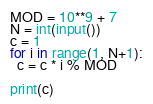Convert code to text. <code><loc_0><loc_0><loc_500><loc_500><_Python_>MOD = 10**9 + 7
N = int(input())
c = 1
for i in range(1, N+1):
  c = c * i % MOD

print(c)</code> 